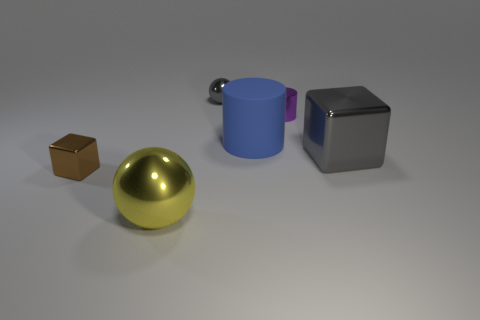Is the number of tiny brown things in front of the tiny cylinder greater than the number of big gray metallic objects that are in front of the large yellow metal object?
Offer a terse response. Yes. Are the big block and the large blue object to the left of the purple shiny object made of the same material?
Your response must be concise. No. What color is the large cube?
Offer a very short reply. Gray. The gray shiny object that is on the right side of the purple thing has what shape?
Your response must be concise. Cube. How many purple objects are either big rubber things or tiny metallic cylinders?
Ensure brevity in your answer.  1. What color is the big block that is the same material as the purple cylinder?
Offer a very short reply. Gray. Does the tiny metal block have the same color as the big thing that is in front of the big gray metallic object?
Give a very brief answer. No. What is the color of the object that is behind the big blue rubber cylinder and in front of the gray sphere?
Provide a short and direct response. Purple. How many tiny purple shiny things are behind the metallic cylinder?
Offer a very short reply. 0. How many things are matte objects or objects in front of the gray sphere?
Offer a very short reply. 5. 